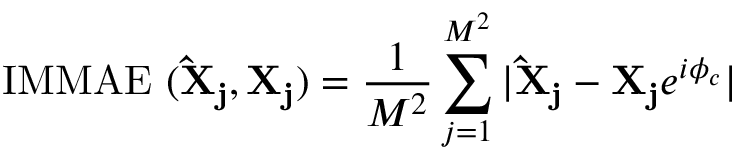Convert formula to latex. <formula><loc_0><loc_0><loc_500><loc_500>I M M A E \ ( \hat { X } _ { j } , X _ { j } ) = \frac { 1 } { M ^ { 2 } } \sum _ { j = 1 } ^ { M ^ { 2 } } | \hat { X } _ { j } - X _ { j } e ^ { i \phi _ { c } } |</formula> 